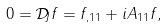Convert formula to latex. <formula><loc_0><loc_0><loc_500><loc_500>0 = { \mathcal { D } } _ { J } f = f _ { , 1 1 } + i A _ { 1 1 } f ,</formula> 